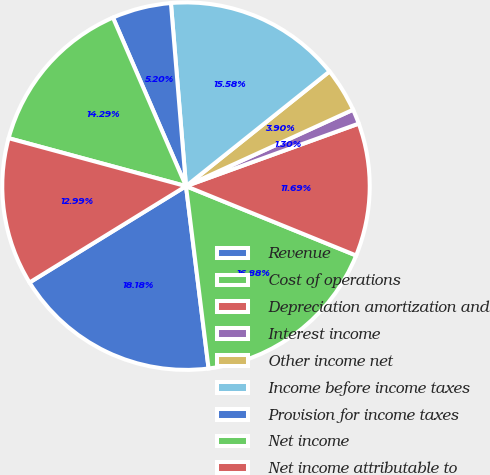Convert chart. <chart><loc_0><loc_0><loc_500><loc_500><pie_chart><fcel>Revenue<fcel>Cost of operations<fcel>Depreciation amortization and<fcel>Interest income<fcel>Other income net<fcel>Income before income taxes<fcel>Provision for income taxes<fcel>Net income<fcel>Net income attributable to<nl><fcel>18.18%<fcel>16.88%<fcel>11.69%<fcel>1.3%<fcel>3.9%<fcel>15.58%<fcel>5.2%<fcel>14.29%<fcel>12.99%<nl></chart> 